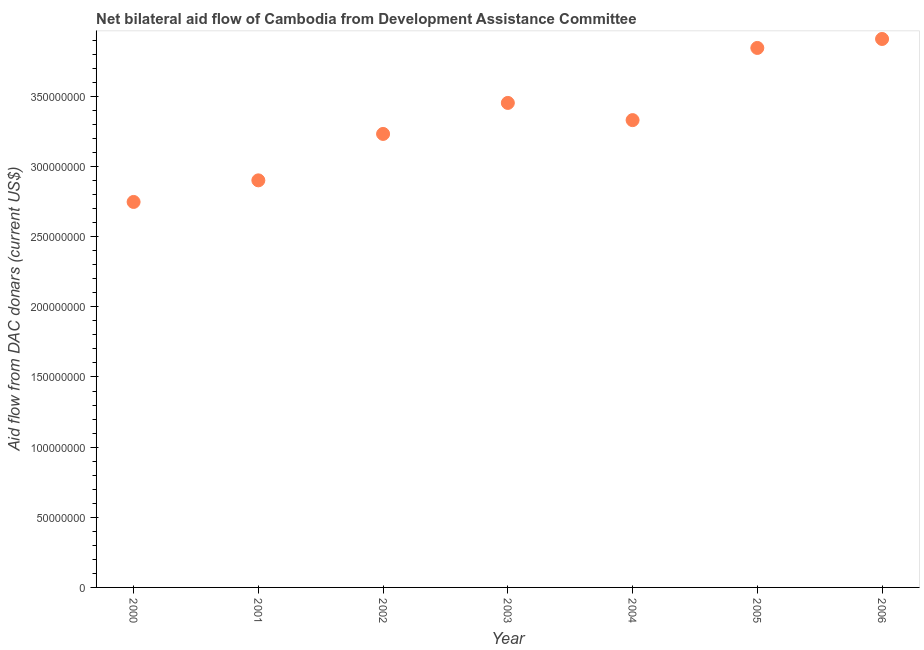What is the net bilateral aid flows from dac donors in 2002?
Give a very brief answer. 3.23e+08. Across all years, what is the maximum net bilateral aid flows from dac donors?
Make the answer very short. 3.91e+08. Across all years, what is the minimum net bilateral aid flows from dac donors?
Keep it short and to the point. 2.75e+08. In which year was the net bilateral aid flows from dac donors maximum?
Offer a terse response. 2006. What is the sum of the net bilateral aid flows from dac donors?
Offer a terse response. 2.34e+09. What is the difference between the net bilateral aid flows from dac donors in 2001 and 2006?
Make the answer very short. -1.01e+08. What is the average net bilateral aid flows from dac donors per year?
Your answer should be compact. 3.35e+08. What is the median net bilateral aid flows from dac donors?
Give a very brief answer. 3.33e+08. Do a majority of the years between 2005 and 2004 (inclusive) have net bilateral aid flows from dac donors greater than 130000000 US$?
Offer a very short reply. No. What is the ratio of the net bilateral aid flows from dac donors in 2003 to that in 2005?
Keep it short and to the point. 0.9. Is the net bilateral aid flows from dac donors in 2001 less than that in 2003?
Provide a short and direct response. Yes. Is the difference between the net bilateral aid flows from dac donors in 2000 and 2005 greater than the difference between any two years?
Give a very brief answer. No. What is the difference between the highest and the second highest net bilateral aid flows from dac donors?
Give a very brief answer. 6.39e+06. What is the difference between the highest and the lowest net bilateral aid flows from dac donors?
Keep it short and to the point. 1.16e+08. How many years are there in the graph?
Offer a terse response. 7. What is the difference between two consecutive major ticks on the Y-axis?
Give a very brief answer. 5.00e+07. Are the values on the major ticks of Y-axis written in scientific E-notation?
Keep it short and to the point. No. What is the title of the graph?
Offer a very short reply. Net bilateral aid flow of Cambodia from Development Assistance Committee. What is the label or title of the X-axis?
Your response must be concise. Year. What is the label or title of the Y-axis?
Keep it short and to the point. Aid flow from DAC donars (current US$). What is the Aid flow from DAC donars (current US$) in 2000?
Provide a succinct answer. 2.75e+08. What is the Aid flow from DAC donars (current US$) in 2001?
Your response must be concise. 2.90e+08. What is the Aid flow from DAC donars (current US$) in 2002?
Offer a very short reply. 3.23e+08. What is the Aid flow from DAC donars (current US$) in 2003?
Your answer should be very brief. 3.45e+08. What is the Aid flow from DAC donars (current US$) in 2004?
Ensure brevity in your answer.  3.33e+08. What is the Aid flow from DAC donars (current US$) in 2005?
Keep it short and to the point. 3.85e+08. What is the Aid flow from DAC donars (current US$) in 2006?
Offer a terse response. 3.91e+08. What is the difference between the Aid flow from DAC donars (current US$) in 2000 and 2001?
Provide a short and direct response. -1.54e+07. What is the difference between the Aid flow from DAC donars (current US$) in 2000 and 2002?
Give a very brief answer. -4.85e+07. What is the difference between the Aid flow from DAC donars (current US$) in 2000 and 2003?
Offer a terse response. -7.06e+07. What is the difference between the Aid flow from DAC donars (current US$) in 2000 and 2004?
Provide a succinct answer. -5.83e+07. What is the difference between the Aid flow from DAC donars (current US$) in 2000 and 2005?
Give a very brief answer. -1.10e+08. What is the difference between the Aid flow from DAC donars (current US$) in 2000 and 2006?
Offer a very short reply. -1.16e+08. What is the difference between the Aid flow from DAC donars (current US$) in 2001 and 2002?
Provide a short and direct response. -3.31e+07. What is the difference between the Aid flow from DAC donars (current US$) in 2001 and 2003?
Your answer should be very brief. -5.52e+07. What is the difference between the Aid flow from DAC donars (current US$) in 2001 and 2004?
Your response must be concise. -4.29e+07. What is the difference between the Aid flow from DAC donars (current US$) in 2001 and 2005?
Provide a short and direct response. -9.44e+07. What is the difference between the Aid flow from DAC donars (current US$) in 2001 and 2006?
Your response must be concise. -1.01e+08. What is the difference between the Aid flow from DAC donars (current US$) in 2002 and 2003?
Your answer should be very brief. -2.21e+07. What is the difference between the Aid flow from DAC donars (current US$) in 2002 and 2004?
Give a very brief answer. -9.84e+06. What is the difference between the Aid flow from DAC donars (current US$) in 2002 and 2005?
Ensure brevity in your answer.  -6.13e+07. What is the difference between the Aid flow from DAC donars (current US$) in 2002 and 2006?
Offer a very short reply. -6.77e+07. What is the difference between the Aid flow from DAC donars (current US$) in 2003 and 2004?
Give a very brief answer. 1.23e+07. What is the difference between the Aid flow from DAC donars (current US$) in 2003 and 2005?
Keep it short and to the point. -3.92e+07. What is the difference between the Aid flow from DAC donars (current US$) in 2003 and 2006?
Keep it short and to the point. -4.56e+07. What is the difference between the Aid flow from DAC donars (current US$) in 2004 and 2005?
Provide a succinct answer. -5.14e+07. What is the difference between the Aid flow from DAC donars (current US$) in 2004 and 2006?
Your answer should be compact. -5.78e+07. What is the difference between the Aid flow from DAC donars (current US$) in 2005 and 2006?
Make the answer very short. -6.39e+06. What is the ratio of the Aid flow from DAC donars (current US$) in 2000 to that in 2001?
Provide a short and direct response. 0.95. What is the ratio of the Aid flow from DAC donars (current US$) in 2000 to that in 2003?
Provide a succinct answer. 0.8. What is the ratio of the Aid flow from DAC donars (current US$) in 2000 to that in 2004?
Your response must be concise. 0.82. What is the ratio of the Aid flow from DAC donars (current US$) in 2000 to that in 2005?
Provide a short and direct response. 0.71. What is the ratio of the Aid flow from DAC donars (current US$) in 2000 to that in 2006?
Ensure brevity in your answer.  0.7. What is the ratio of the Aid flow from DAC donars (current US$) in 2001 to that in 2002?
Offer a very short reply. 0.9. What is the ratio of the Aid flow from DAC donars (current US$) in 2001 to that in 2003?
Keep it short and to the point. 0.84. What is the ratio of the Aid flow from DAC donars (current US$) in 2001 to that in 2004?
Give a very brief answer. 0.87. What is the ratio of the Aid flow from DAC donars (current US$) in 2001 to that in 2005?
Give a very brief answer. 0.76. What is the ratio of the Aid flow from DAC donars (current US$) in 2001 to that in 2006?
Make the answer very short. 0.74. What is the ratio of the Aid flow from DAC donars (current US$) in 2002 to that in 2003?
Provide a short and direct response. 0.94. What is the ratio of the Aid flow from DAC donars (current US$) in 2002 to that in 2004?
Make the answer very short. 0.97. What is the ratio of the Aid flow from DAC donars (current US$) in 2002 to that in 2005?
Offer a very short reply. 0.84. What is the ratio of the Aid flow from DAC donars (current US$) in 2002 to that in 2006?
Provide a short and direct response. 0.83. What is the ratio of the Aid flow from DAC donars (current US$) in 2003 to that in 2004?
Offer a terse response. 1.04. What is the ratio of the Aid flow from DAC donars (current US$) in 2003 to that in 2005?
Your response must be concise. 0.9. What is the ratio of the Aid flow from DAC donars (current US$) in 2003 to that in 2006?
Keep it short and to the point. 0.88. What is the ratio of the Aid flow from DAC donars (current US$) in 2004 to that in 2005?
Offer a terse response. 0.87. What is the ratio of the Aid flow from DAC donars (current US$) in 2004 to that in 2006?
Your answer should be compact. 0.85. 